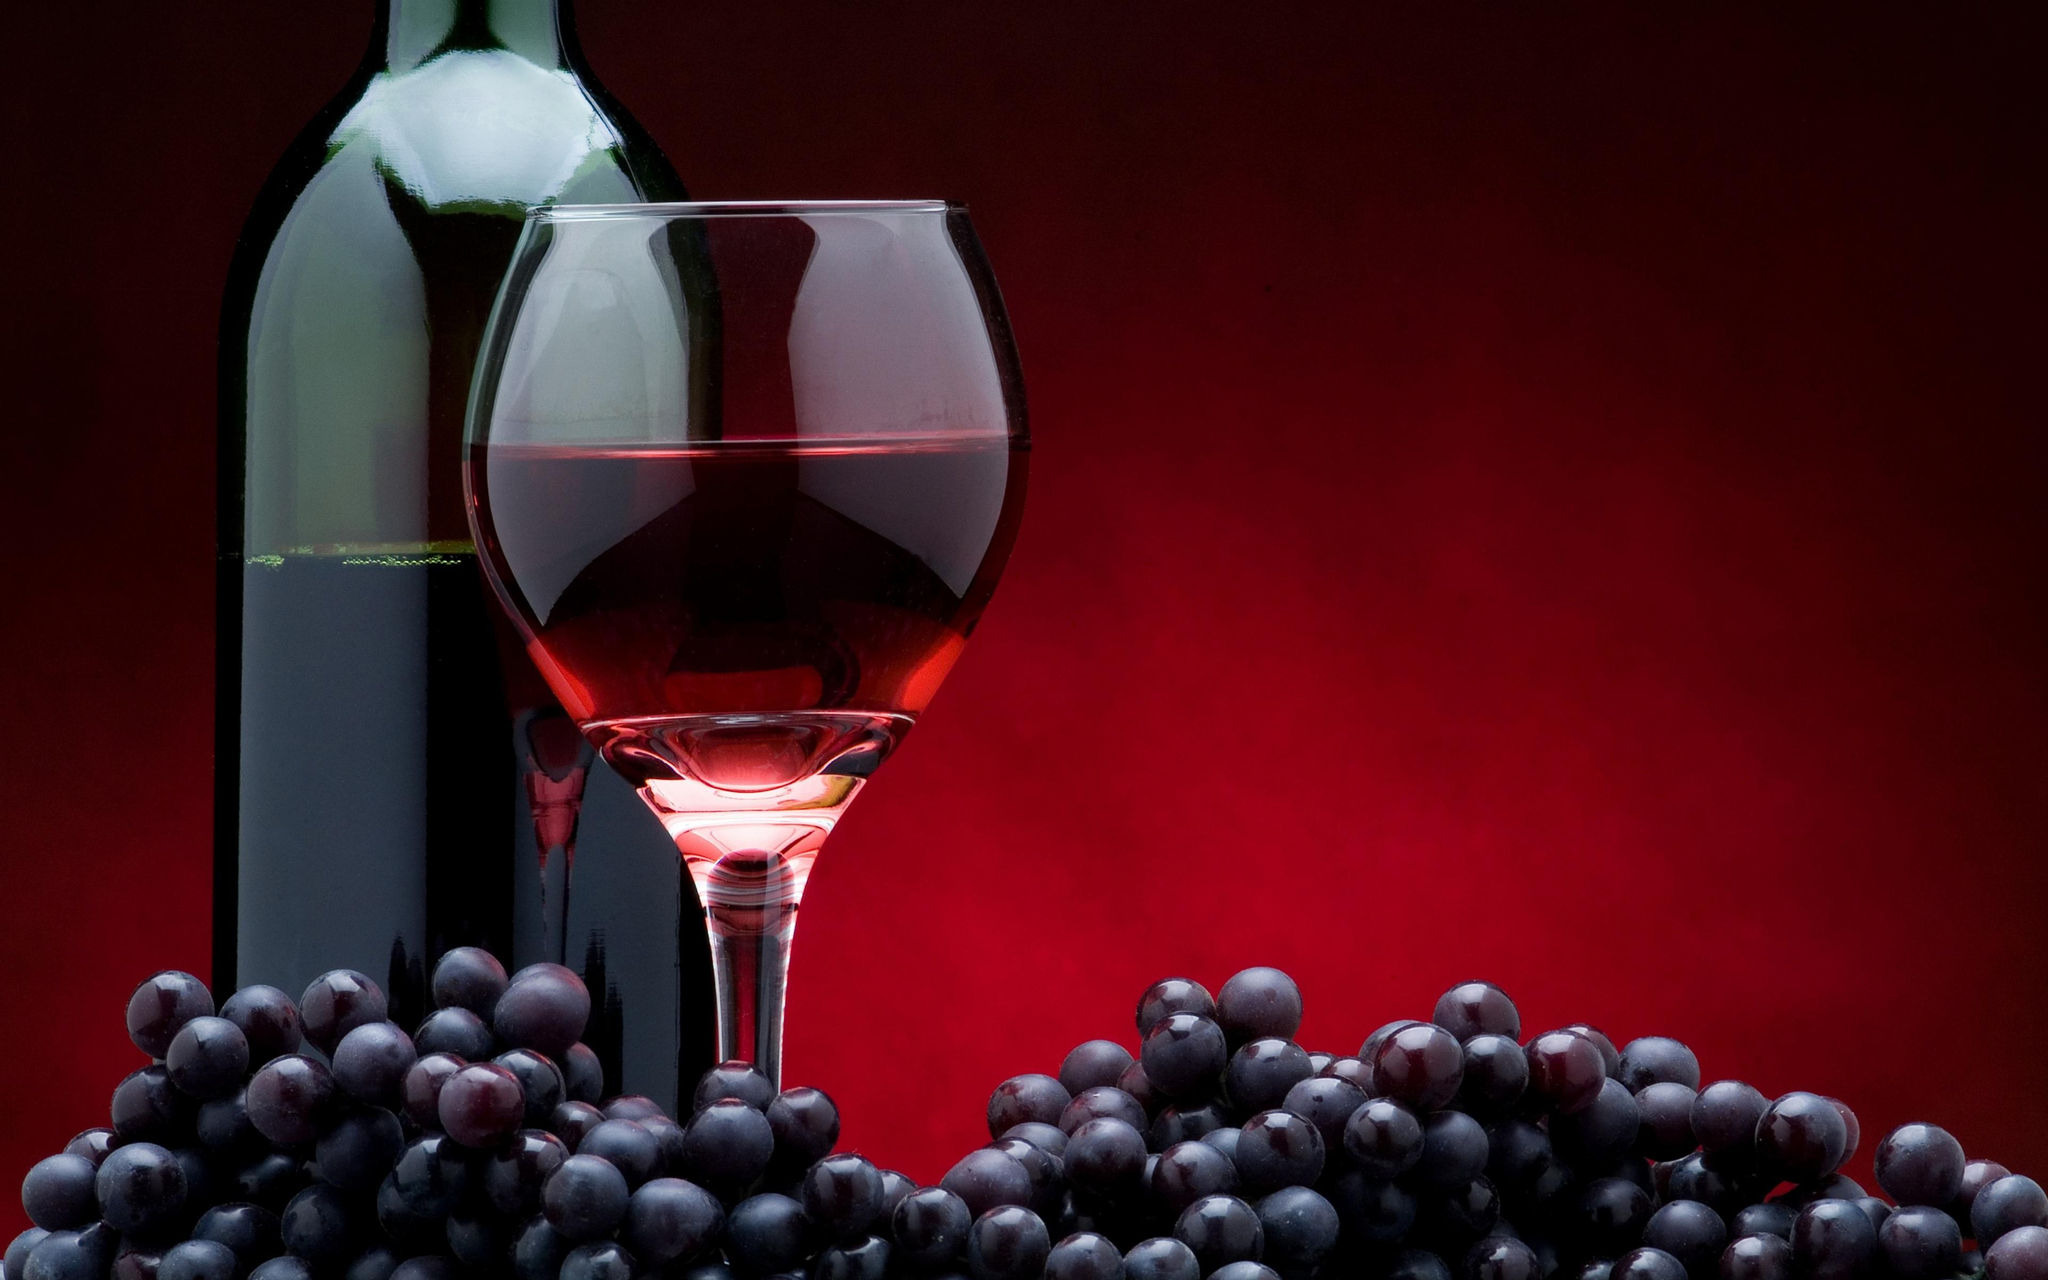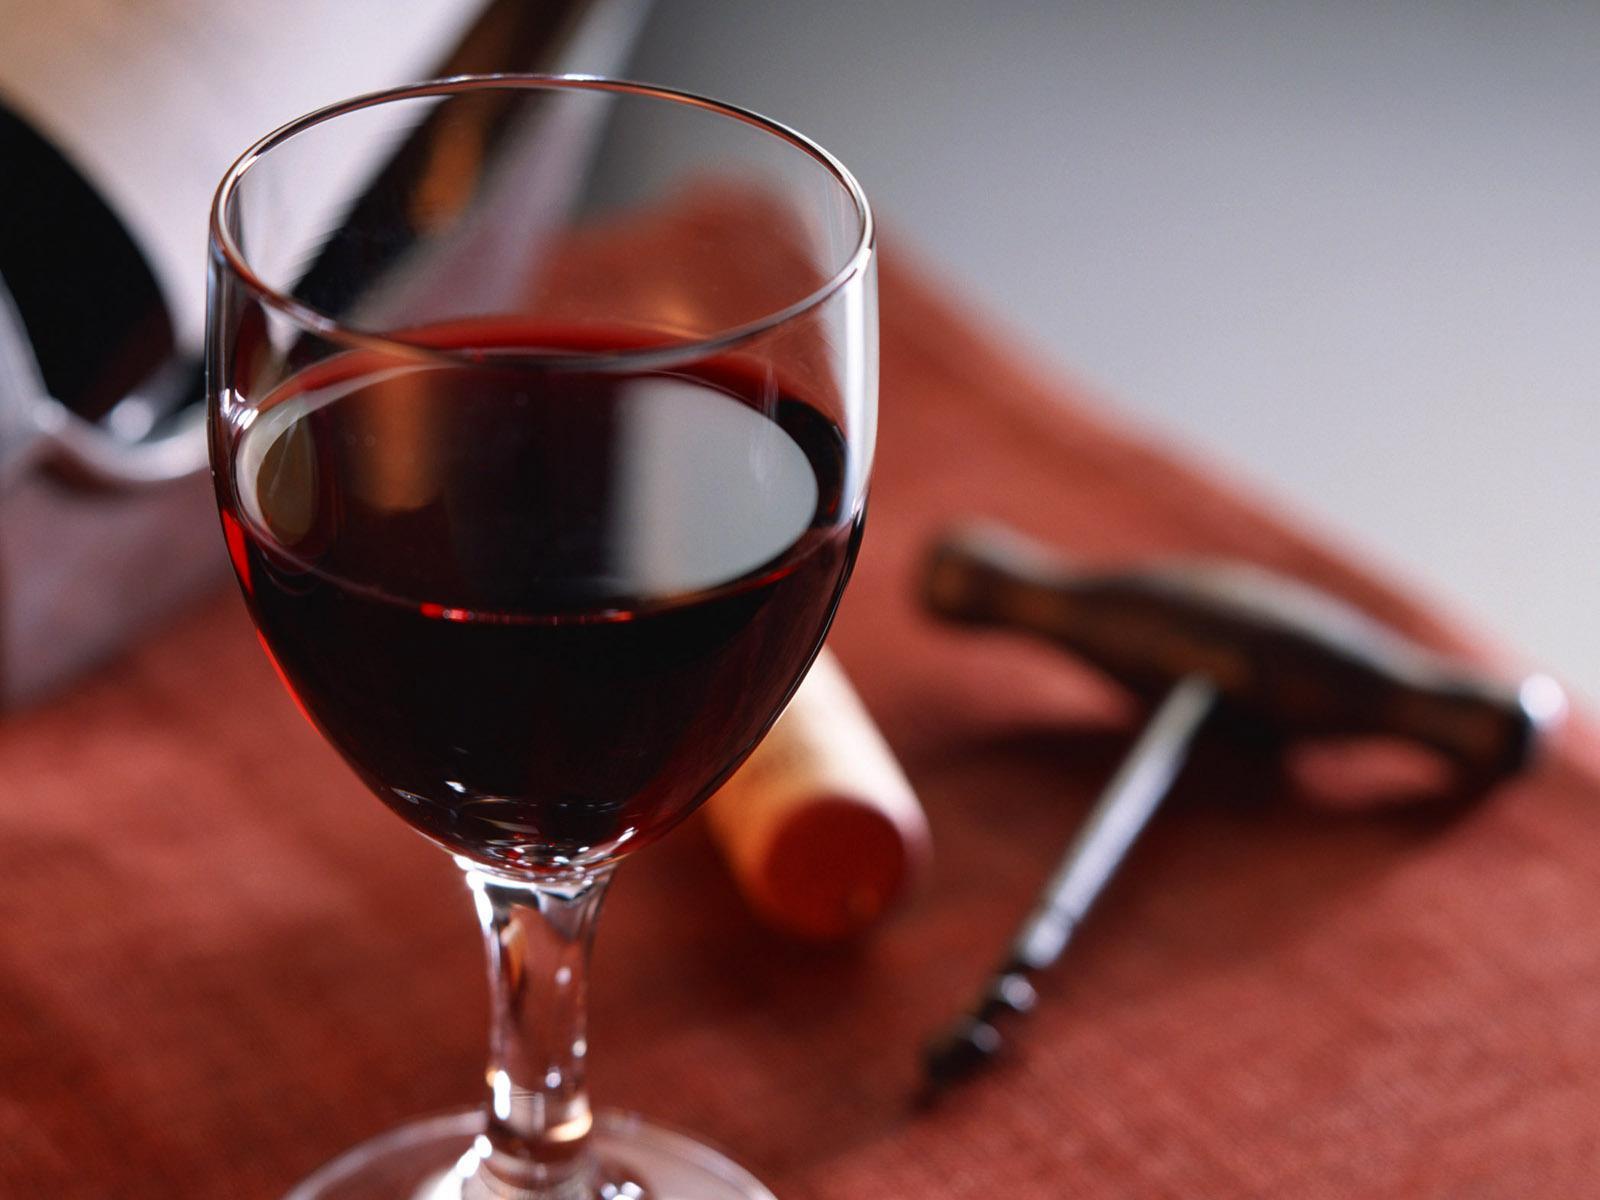The first image is the image on the left, the second image is the image on the right. Evaluate the accuracy of this statement regarding the images: "There are more than two glasses with wine in them". Is it true? Answer yes or no. No. The first image is the image on the left, the second image is the image on the right. Assess this claim about the two images: "There are four wine glasses, and some of them are in front of the others.". Correct or not? Answer yes or no. No. 